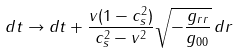Convert formula to latex. <formula><loc_0><loc_0><loc_500><loc_500>d t \rightarrow d t + \frac { v ( 1 - c _ { s } ^ { 2 } ) } { c _ { s } ^ { 2 } - v ^ { 2 } } \sqrt { - \frac { g _ { r r } } { g _ { 0 0 } } } \, d r</formula> 